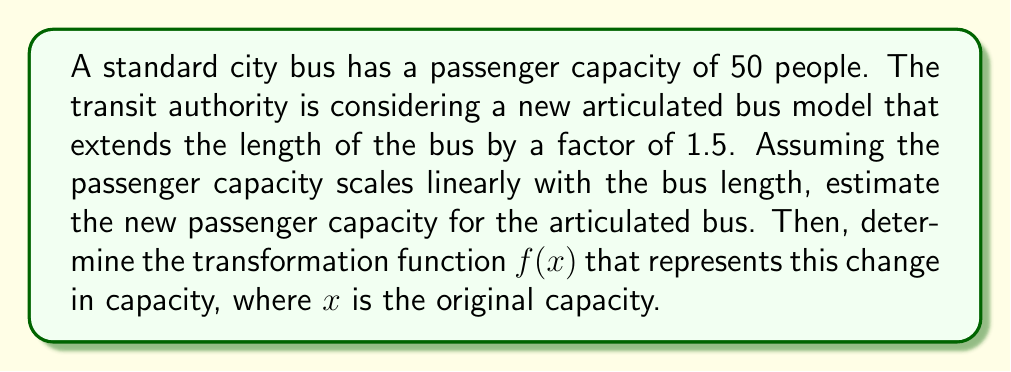Help me with this question. Let's approach this step-by-step:

1) The original bus capacity is 50 passengers.

2) The new bus is 1.5 times longer than the original bus.

3) Assuming linear scaling, the new capacity will also be 1.5 times the original:
   $$\text{New Capacity} = 50 \times 1.5 = 75 \text{ passengers}$$

4) To find the transformation function $f(x)$, we need to express the new capacity in terms of the original capacity $x$:
   $$f(x) = 1.5x$$

5) This transformation can be described as a dilation with a scale factor of 1.5.

6) To verify:
   $$f(50) = 1.5 \times 50 = 75$$
   
   This matches our calculated new capacity.
Answer: $f(x) = 1.5x$ 